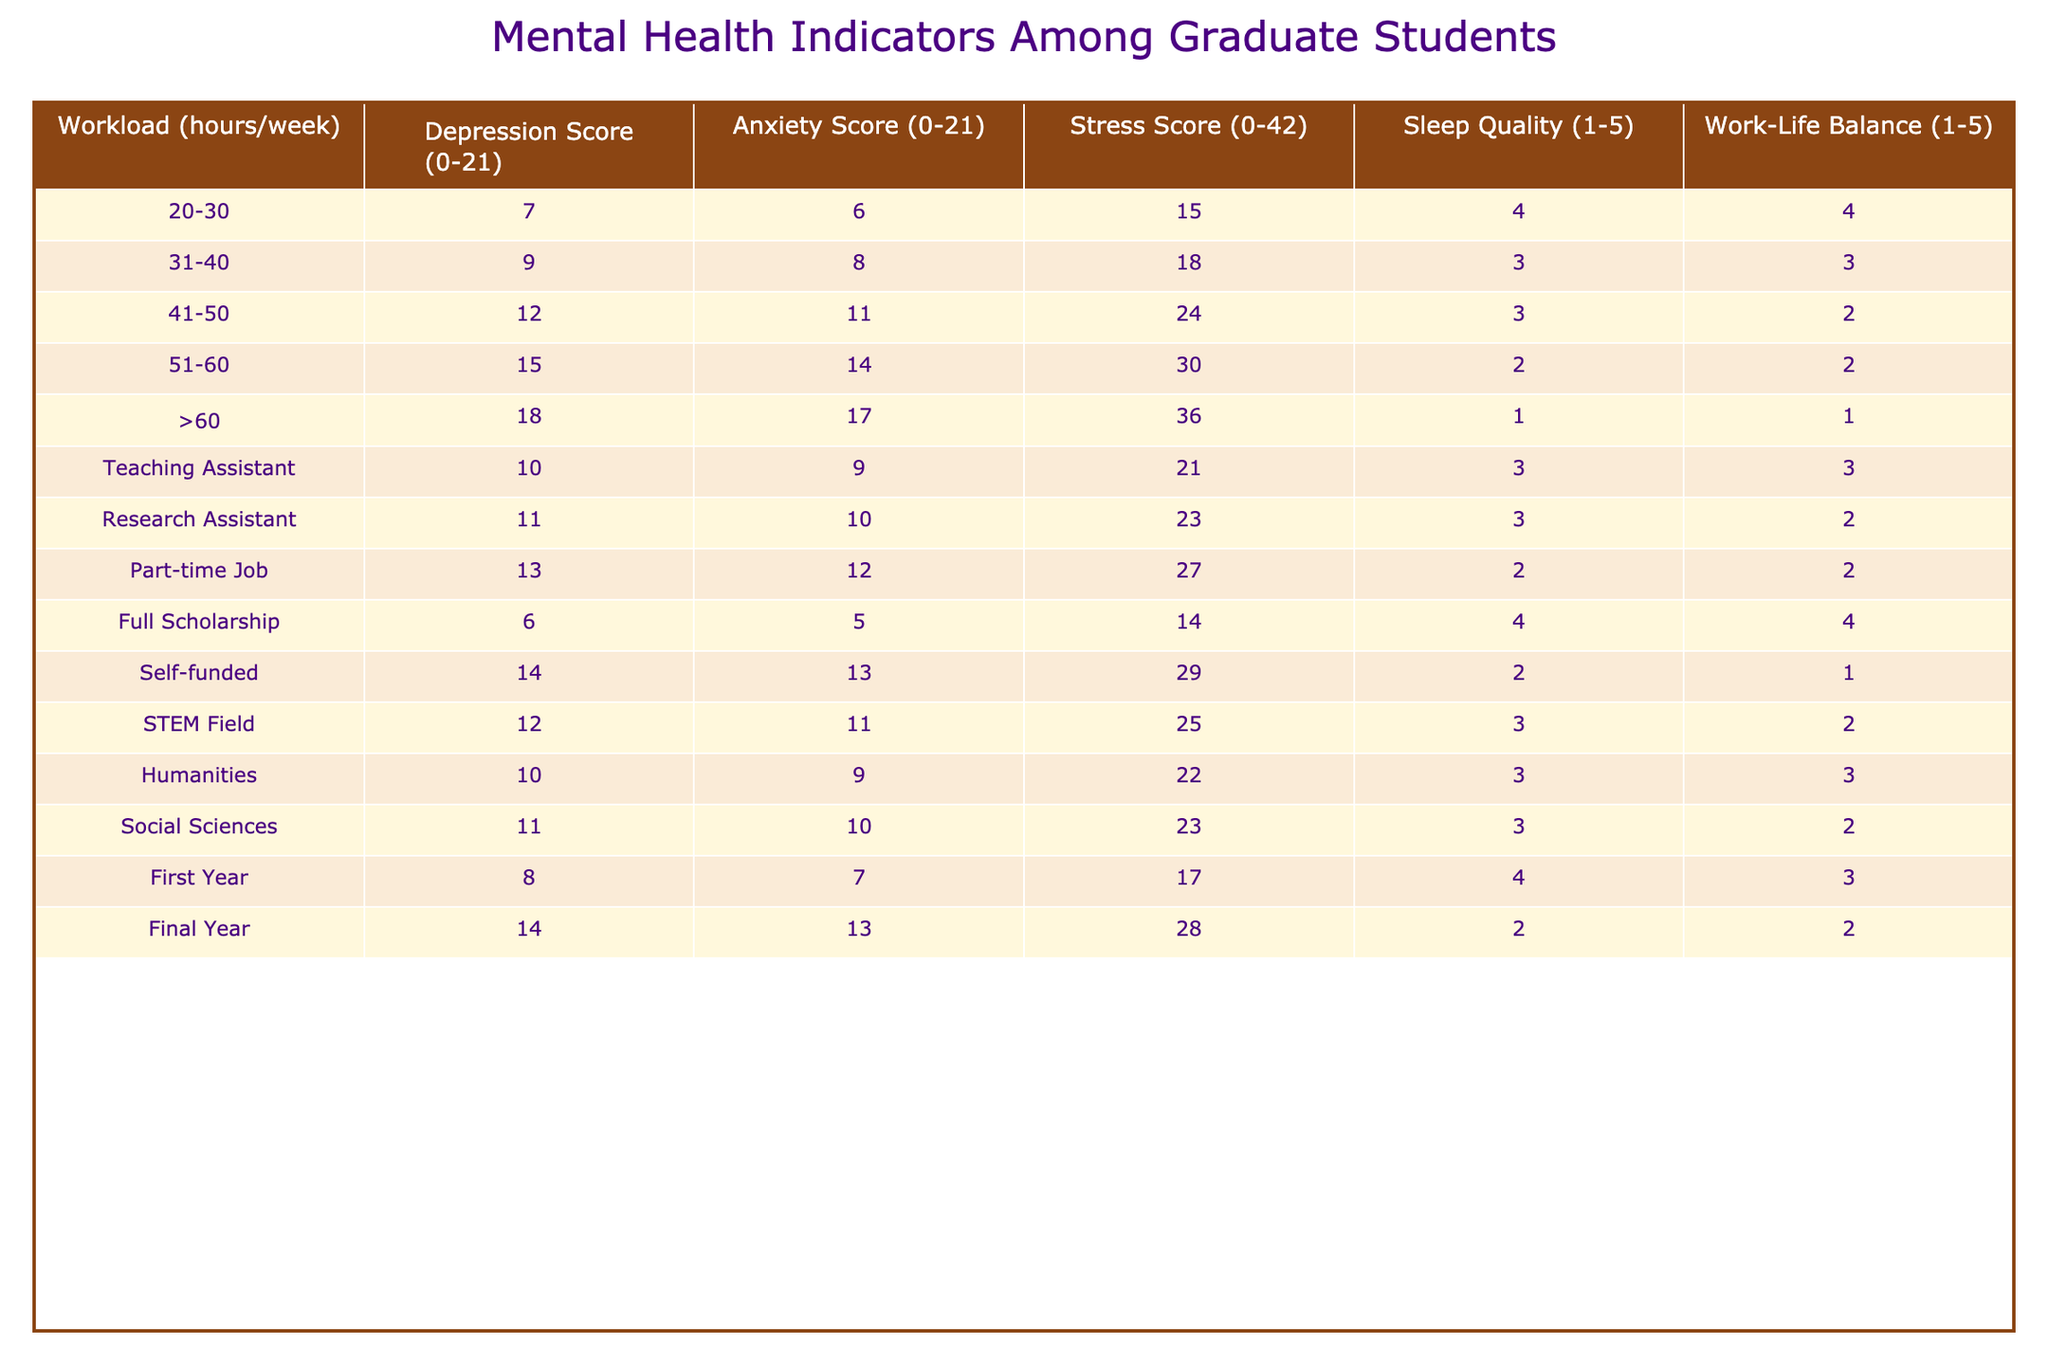What is the Depression Score for students working 51-60 hours per week? Looking in the table, for the workload category "51-60" hours, the Depression Score is explicitly listed as 15.
Answer: 15 What is the maximum Anxiety Score recorded in the table? By examining the table, the highest Anxiety Score is found in the ">60" hours workload category, which is 17.
Answer: 17 What is the average Stress Score for students who are Research Assistants and Teaching Assistants? The Stress Scores for Teaching Assistants and Research Assistants are 21 and 23, respectively. The sum is 21 + 23 = 44, and there are 2 data points, so the average is 44/2 = 22.
Answer: 22 Is the Sleep Quality for students with part-time jobs higher than those who self-funded their education? The Sleep Quality for students with part-time jobs is 2, while for students who self-funded it is also 2. Since both values are equal, the statement is false.
Answer: No What is the difference in Stress Scores between students working 41-50 hours and those in the Social Sciences field? For 41-50 hours, the Stress Score is 24, and for Social Sciences, it is 23. The difference is 24 - 23 = 1.
Answer: 1 Which group shows the best Work-Life Balance score, and what is that score? The best Work-Life Balance score of 4 appears in the "20-30" hours workload category and under "Full Scholarship." Both groups are tied for the best score.
Answer: 4 How does the Depression Score change as students' workloads increase from 20-30 hours to >60 hours? The Depression Score increases from 7 for 20-30 hours to 18 for >60 hours, showing an increase of 11 points (18 - 7 = 11).
Answer: Increase of 11 points Is there a correlation between workload and Sleep Quality? Examining the table, as the workload increases, the Sleep Quality generally decreases, indicating a negative correlation between these two variables. Therefore, the statement is true.
Answer: Yes What is the combined Stress Score for both First Year and Final Year students? The Stress Score for First Year students is 17, and for Final Year students, it's 28. Adding these gives 17 + 28 = 45.
Answer: 45 How does the average Depression Score for students with teaching and research assistant roles compare to that of STEM students? The average Depression Score for Teaching Assistants is 10 and for Research Assistants is 11, giving a combined average of (10 + 11)/2 = 10.5, while for STEM students, it is 12. The assistant average is lower than STEM.
Answer: Lower than STEM 